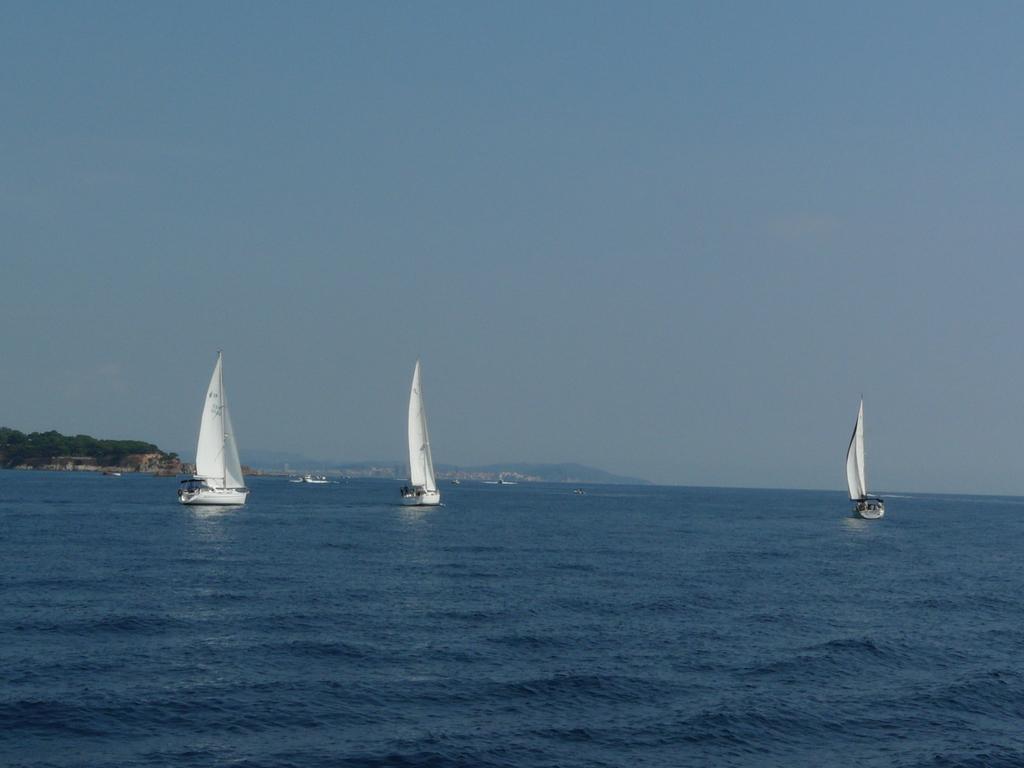Can you describe this image briefly? In this picture we can see boats on water, mountains, trees and in the background we can see the sky. 